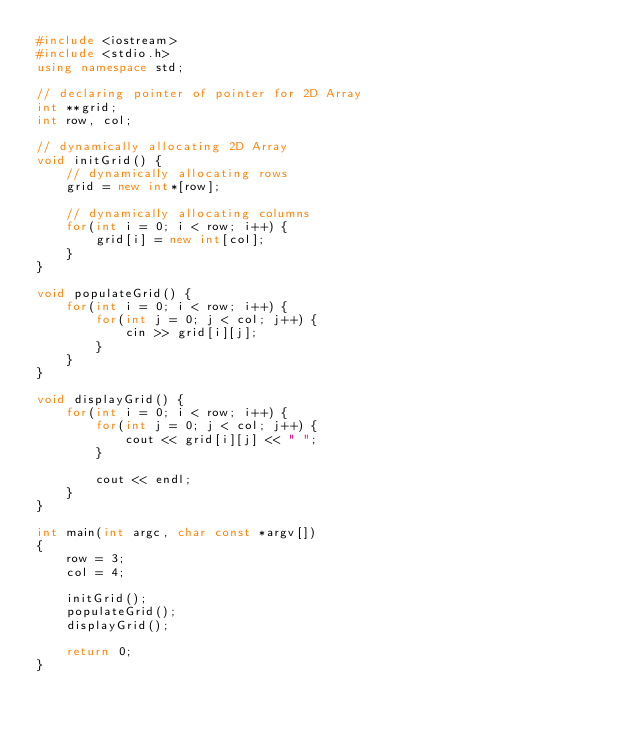<code> <loc_0><loc_0><loc_500><loc_500><_C++_>#include <iostream>
#include <stdio.h>
using namespace std;

// declaring pointer of pointer for 2D Array
int **grid;
int row, col;

// dynamically allocating 2D Array
void initGrid() {
	// dynamically allocating rows
	grid = new int*[row];

	// dynamically allocating columns
	for(int i = 0; i < row; i++) {
		grid[i] = new int[col];
	}
}

void populateGrid() {
	for(int i = 0; i < row; i++) {
		for(int j = 0; j < col; j++) {
			cin >> grid[i][j];
		}
	}
}

void displayGrid() {
	for(int i = 0; i < row; i++) {
		for(int j = 0; j < col; j++) {
			cout << grid[i][j] << " ";
		}

		cout << endl;
	}
}

int main(int argc, char const *argv[])
{
	row = 3;
	col = 4;

	initGrid();
	populateGrid();
	displayGrid();

	return 0;
}</code> 